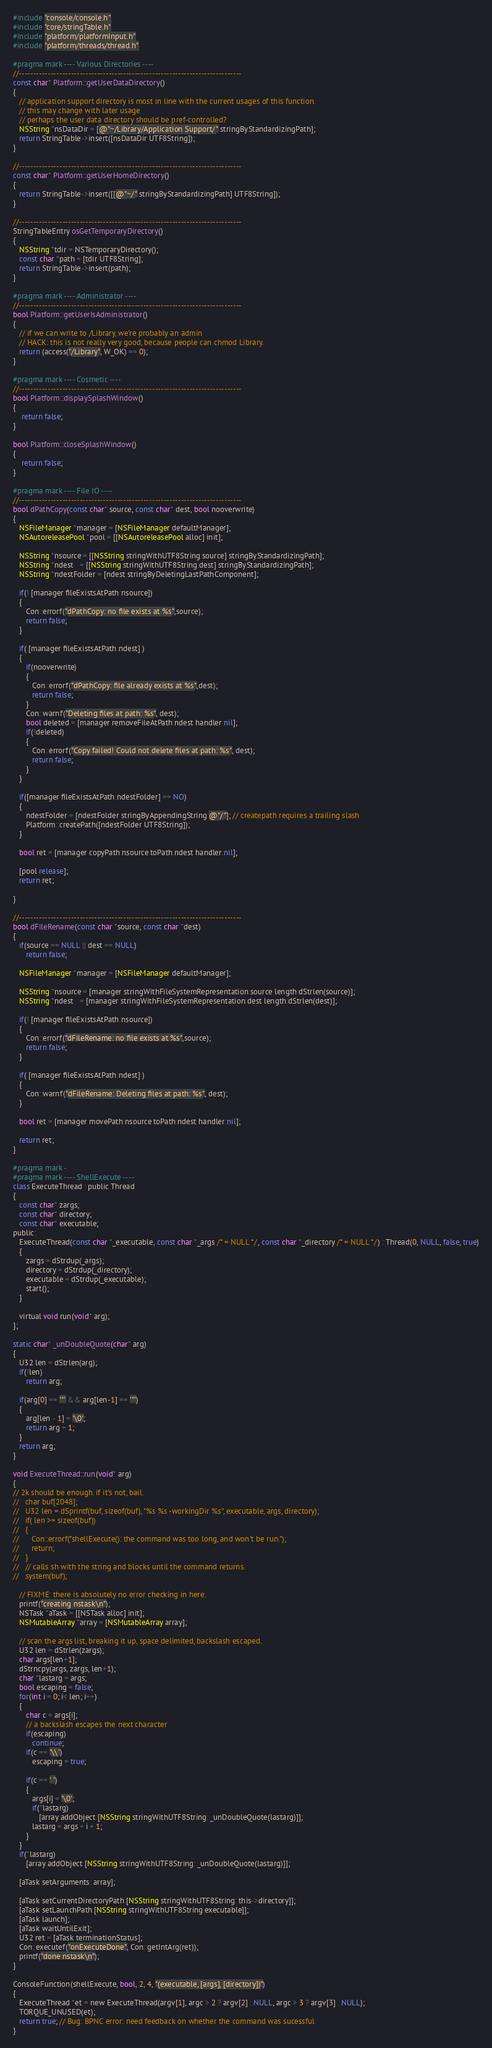<code> <loc_0><loc_0><loc_500><loc_500><_ObjectiveC_>#include "console/console.h"
#include "core/stringTable.h"
#include "platform/platformInput.h"
#include "platform/threads/thread.h"

#pragma mark ---- Various Directories ----
//-----------------------------------------------------------------------------
const char* Platform::getUserDataDirectory() 
{
   // application support directory is most in line with the current usages of this function.
   // this may change with later usage
   // perhaps the user data directory should be pref-controlled?
   NSString *nsDataDir = [@"~/Library/Application Support/" stringByStandardizingPath];
   return StringTable->insert([nsDataDir UTF8String]);
}

//-----------------------------------------------------------------------------
const char* Platform::getUserHomeDirectory() 
{
   return StringTable->insert([[@"~/" stringByStandardizingPath] UTF8String]);
}

//-----------------------------------------------------------------------------
StringTableEntry osGetTemporaryDirectory()
{
   NSString *tdir = NSTemporaryDirectory();
   const char *path = [tdir UTF8String];
   return StringTable->insert(path);
}

#pragma mark ---- Administrator ----
//-----------------------------------------------------------------------------
bool Platform::getUserIsAdministrator()
{
   // if we can write to /Library, we're probably an admin
   // HACK: this is not really very good, because people can chmod Library.
   return (access("/Library", W_OK) == 0);
}

#pragma mark ---- Cosmetic ----
//-----------------------------------------------------------------------------
bool Platform::displaySplashWindow()
{
    return false;
}

bool Platform::closeSplashWindow()
{
    return false;
}

#pragma mark ---- File IO ----
//-----------------------------------------------------------------------------
bool dPathCopy(const char* source, const char* dest, bool nooverwrite)
{
   NSFileManager *manager = [NSFileManager defaultManager];
   NSAutoreleasePool *pool = [[NSAutoreleasePool alloc] init];
   
   NSString *nsource = [[NSString stringWithUTF8String:source] stringByStandardizingPath];
   NSString *ndest   = [[NSString stringWithUTF8String:dest] stringByStandardizingPath];
   NSString *ndestFolder = [ndest stringByDeletingLastPathComponent];
   
   if(! [manager fileExistsAtPath:nsource])
   {
      Con::errorf("dPathCopy: no file exists at %s",source);
      return false;
   }
   
   if( [manager fileExistsAtPath:ndest] )
   {
      if(nooverwrite)
      {
         Con::errorf("dPathCopy: file already exists at %s",dest);
         return false;
      }
      Con::warnf("Deleting files at path: %s", dest);
      bool deleted = [manager removeFileAtPath:ndest handler:nil];
      if(!deleted)
      {
         Con::errorf("Copy failed! Could not delete files at path: %s", dest);
         return false;
      }
   }
   
   if([manager fileExistsAtPath:ndestFolder] == NO)
   {
      ndestFolder = [ndestFolder stringByAppendingString:@"/"]; // createpath requires a trailing slash
      Platform::createPath([ndestFolder UTF8String]);
   }
   
   bool ret = [manager copyPath:nsource toPath:ndest handler:nil];
   
   [pool release];
   return ret;
   
}

//-----------------------------------------------------------------------------
bool dFileRename(const char *source, const char *dest)
{
   if(source == NULL || dest == NULL)
      return false;
      
   NSFileManager *manager = [NSFileManager defaultManager];
   
   NSString *nsource = [manager stringWithFileSystemRepresentation:source length:dStrlen(source)];
   NSString *ndest   = [manager stringWithFileSystemRepresentation:dest length:dStrlen(dest)];
   
   if(! [manager fileExistsAtPath:nsource])
   {
      Con::errorf("dFileRename: no file exists at %s",source);
      return false;
   }
   
   if( [manager fileExistsAtPath:ndest] )
   {
      Con::warnf("dFileRename: Deleting files at path: %s", dest);
   }
   
   bool ret = [manager movePath:nsource toPath:ndest handler:nil];
  
   return ret;
}

#pragma mark -
#pragma mark ---- ShellExecute ----
class ExecuteThread : public Thread
{
   const char* zargs;
   const char* directory;
   const char* executable;
public:
   ExecuteThread(const char *_executable, const char *_args /* = NULL */, const char *_directory /* = NULL */) : Thread(0, NULL, false, true)
   {
      zargs = dStrdup(_args);
      directory = dStrdup(_directory);
      executable = dStrdup(_executable);
      start();
   }
   
   virtual void run(void* arg);
};

static char* _unDoubleQuote(char* arg)
{
   U32 len = dStrlen(arg);
   if(!len)
      return arg;
   
   if(arg[0] == '"' && arg[len-1] == '"')
   {
      arg[len - 1] = '\0';
      return arg + 1;
   }
   return arg;
}

void ExecuteThread::run(void* arg)
{
// 2k should be enough. if it's not, bail.
//   char buf[2048];
//   U32 len = dSprintf(buf, sizeof(buf), "%s %s -workingDir %s", executable, args, directory);
//   if( len >= sizeof(buf))
//   {
//      Con::errorf("shellExecute(): the command was too long, and won't be run.");
//      return;
//   }
//   // calls sh with the string and blocks until the command returns.
//   system(buf);

   // FIXME: there is absolutely no error checking in here.
   printf("creating nstask\n");
   NSTask *aTask = [[NSTask alloc] init];
   NSMutableArray *array = [NSMutableArray array];

   // scan the args list, breaking it up, space delimited, backslash escaped.
   U32 len = dStrlen(zargs);
   char args[len+1];
   dStrncpy(args, zargs, len+1);
   char *lastarg = args;
   bool escaping = false;
   for(int i = 0; i< len; i++)
   {
      char c = args[i];
      // a backslash escapes the next character
      if(escaping)      
         continue;
      if(c == '\\')
         escaping = true;
      
      if(c == ' ')
      {
         args[i] = '\0';
         if(*lastarg)
            [array addObject:[NSString stringWithUTF8String: _unDoubleQuote(lastarg)]];
         lastarg = args + i + 1;
      }
   }
   if(*lastarg)
      [array addObject:[NSString stringWithUTF8String: _unDoubleQuote(lastarg)]];

   [aTask setArguments: array];
     
   [aTask setCurrentDirectoryPath:[NSString stringWithUTF8String: this->directory]];
   [aTask setLaunchPath:[NSString stringWithUTF8String:executable]];
   [aTask launch];
   [aTask waitUntilExit];
   U32 ret = [aTask terminationStatus];
   Con::executef("onExecuteDone", Con::getIntArg(ret));
   printf("done nstask\n");
}

ConsoleFunction(shellExecute, bool, 2, 4, "(executable, [args], [directory])")
{
   ExecuteThread *et = new ExecuteThread(argv[1], argc > 2 ? argv[2] : NULL, argc > 3 ? argv[3] : NULL);
   TORQUE_UNUSED(et);
   return true; // Bug: BPNC error: need feedback on whether the command was sucessful
}
</code> 